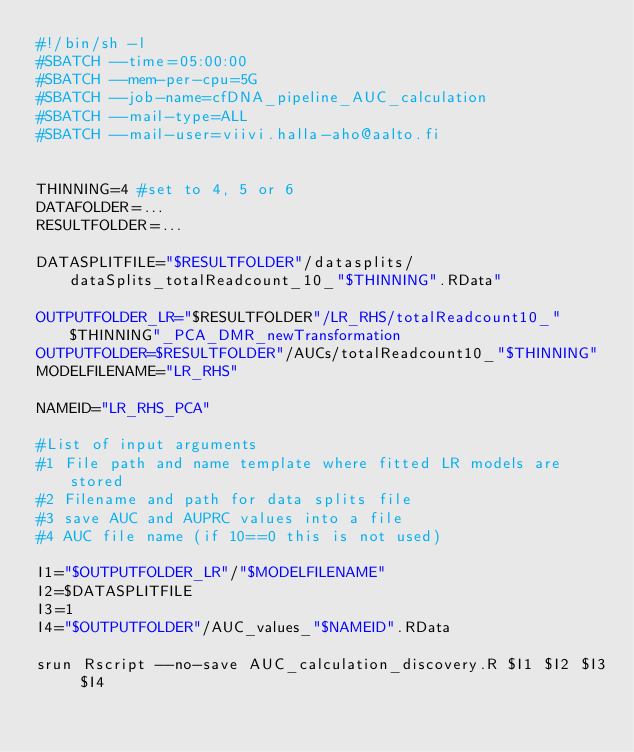Convert code to text. <code><loc_0><loc_0><loc_500><loc_500><_Bash_>#!/bin/sh -l
#SBATCH --time=05:00:00
#SBATCH --mem-per-cpu=5G
#SBATCH --job-name=cfDNA_pipeline_AUC_calculation
#SBATCH --mail-type=ALL
#SBATCH --mail-user=viivi.halla-aho@aalto.fi


THINNING=4 #set to 4, 5 or 6
DATAFOLDER=...
RESULTFOLDER=...

DATASPLITFILE="$RESULTFOLDER"/datasplits/dataSplits_totalReadcount_10_"$THINNING".RData"

OUTPUTFOLDER_LR="$RESULTFOLDER"/LR_RHS/totalReadcount10_"$THINNING"_PCA_DMR_newTransformation
OUTPUTFOLDER=$RESULTFOLDER"/AUCs/totalReadcount10_"$THINNING"
MODELFILENAME="LR_RHS"

NAMEID="LR_RHS_PCA"

#List of input arguments
#1 File path and name template where fitted LR models are stored
#2 Filename and path for data splits file
#3 save AUC and AUPRC values into a file
#4 AUC file name (if 10==0 this is not used)
 
I1="$OUTPUTFOLDER_LR"/"$MODELFILENAME"
I2=$DATASPLITFILE
I3=1
I4="$OUTPUTFOLDER"/AUC_values_"$NAMEID".RData
 
srun Rscript --no-save AUC_calculation_discovery.R $I1 $I2 $I3 $I4
 
</code> 